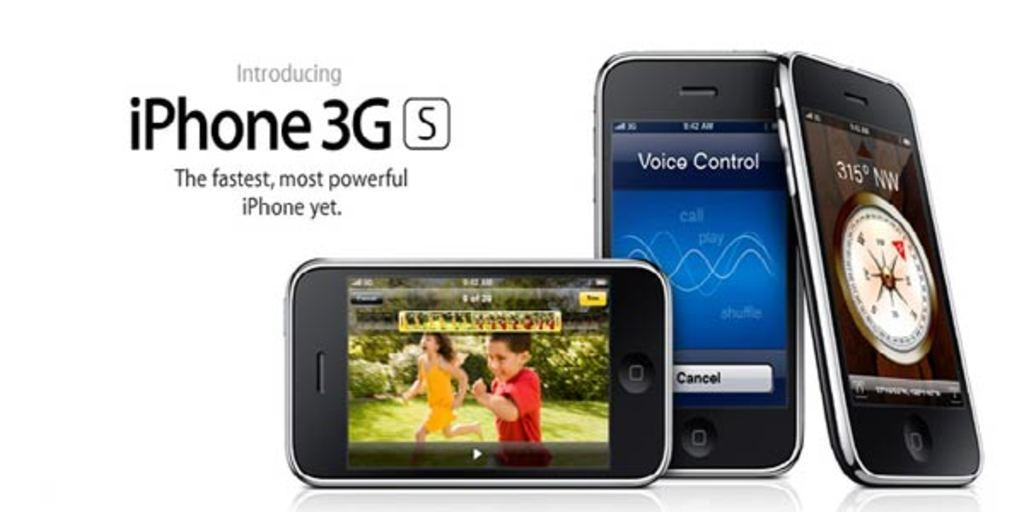<image>
Describe the image concisely. An ad for the iPhone 3GS showing three of them. 